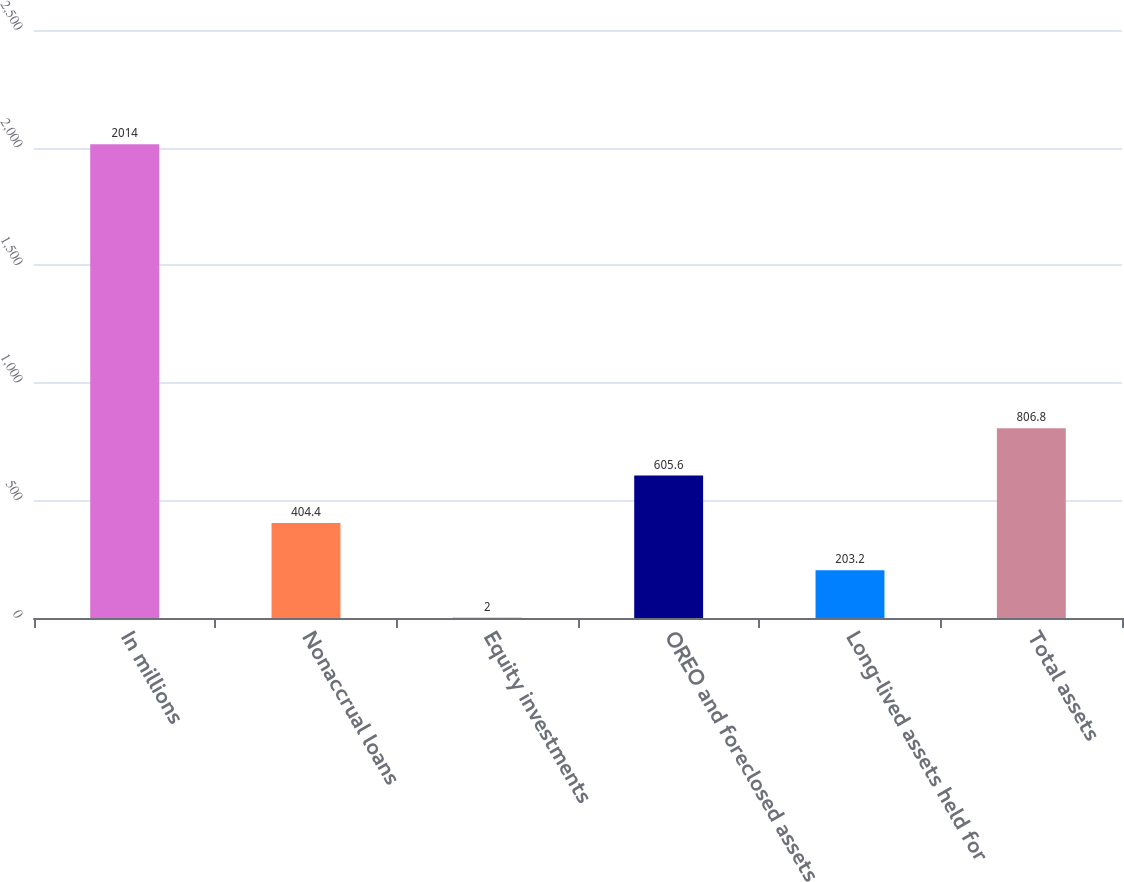Convert chart. <chart><loc_0><loc_0><loc_500><loc_500><bar_chart><fcel>In millions<fcel>Nonaccrual loans<fcel>Equity investments<fcel>OREO and foreclosed assets<fcel>Long-lived assets held for<fcel>Total assets<nl><fcel>2014<fcel>404.4<fcel>2<fcel>605.6<fcel>203.2<fcel>806.8<nl></chart> 